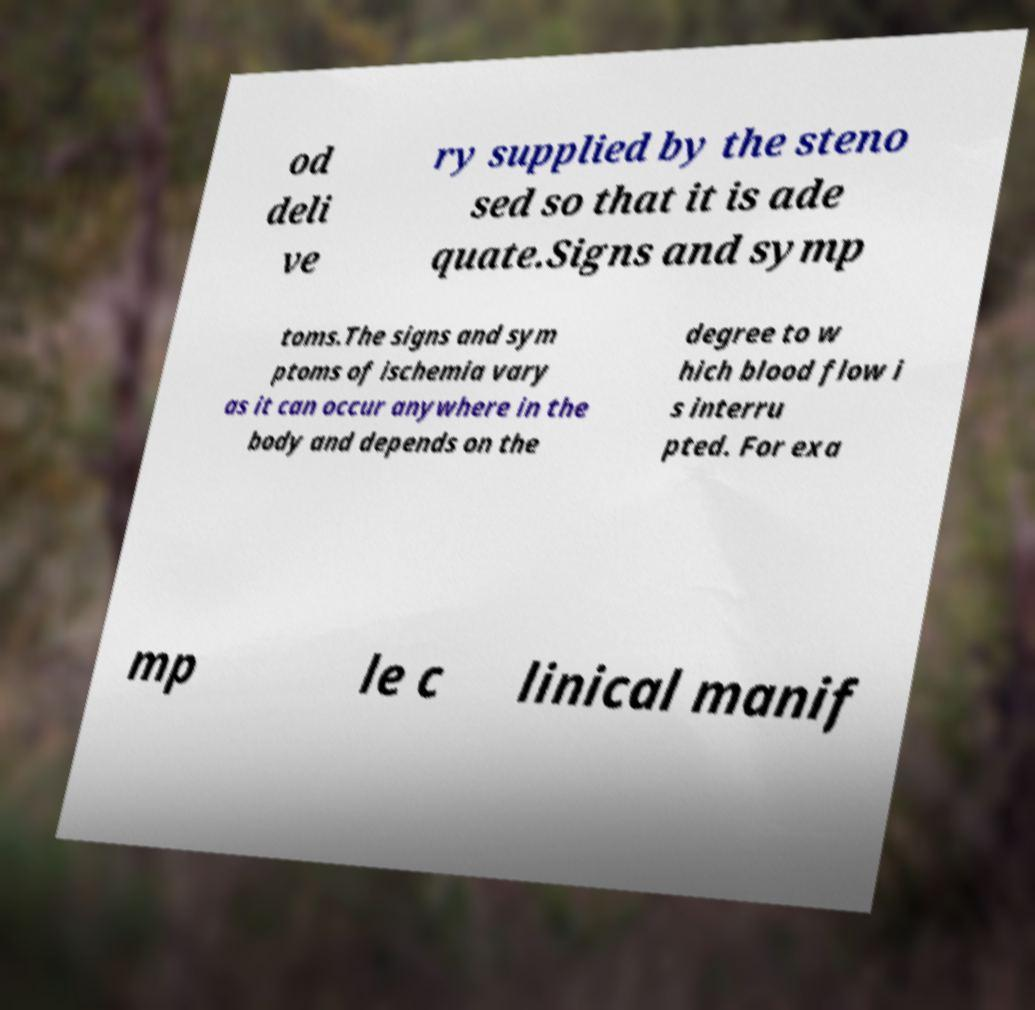What messages or text are displayed in this image? I need them in a readable, typed format. od deli ve ry supplied by the steno sed so that it is ade quate.Signs and symp toms.The signs and sym ptoms of ischemia vary as it can occur anywhere in the body and depends on the degree to w hich blood flow i s interru pted. For exa mp le c linical manif 